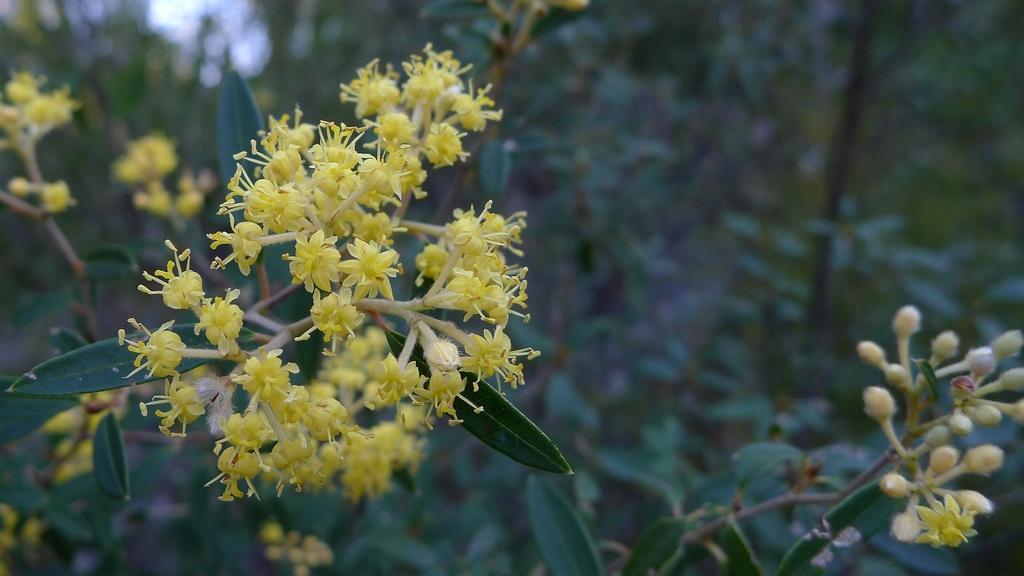Please provide a concise description of this image. Here we can see flowers, buds and green leaves. Background it is blur. 